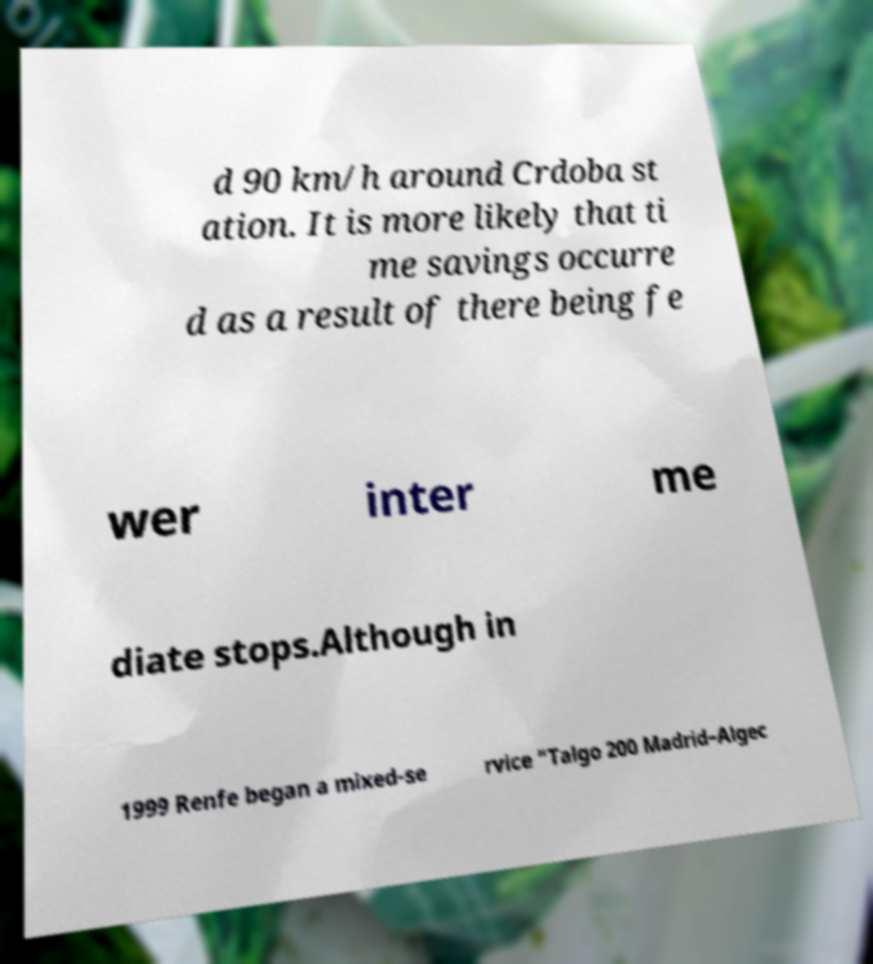There's text embedded in this image that I need extracted. Can you transcribe it verbatim? d 90 km/h around Crdoba st ation. It is more likely that ti me savings occurre d as a result of there being fe wer inter me diate stops.Although in 1999 Renfe began a mixed-se rvice "Talgo 200 Madrid–Algec 